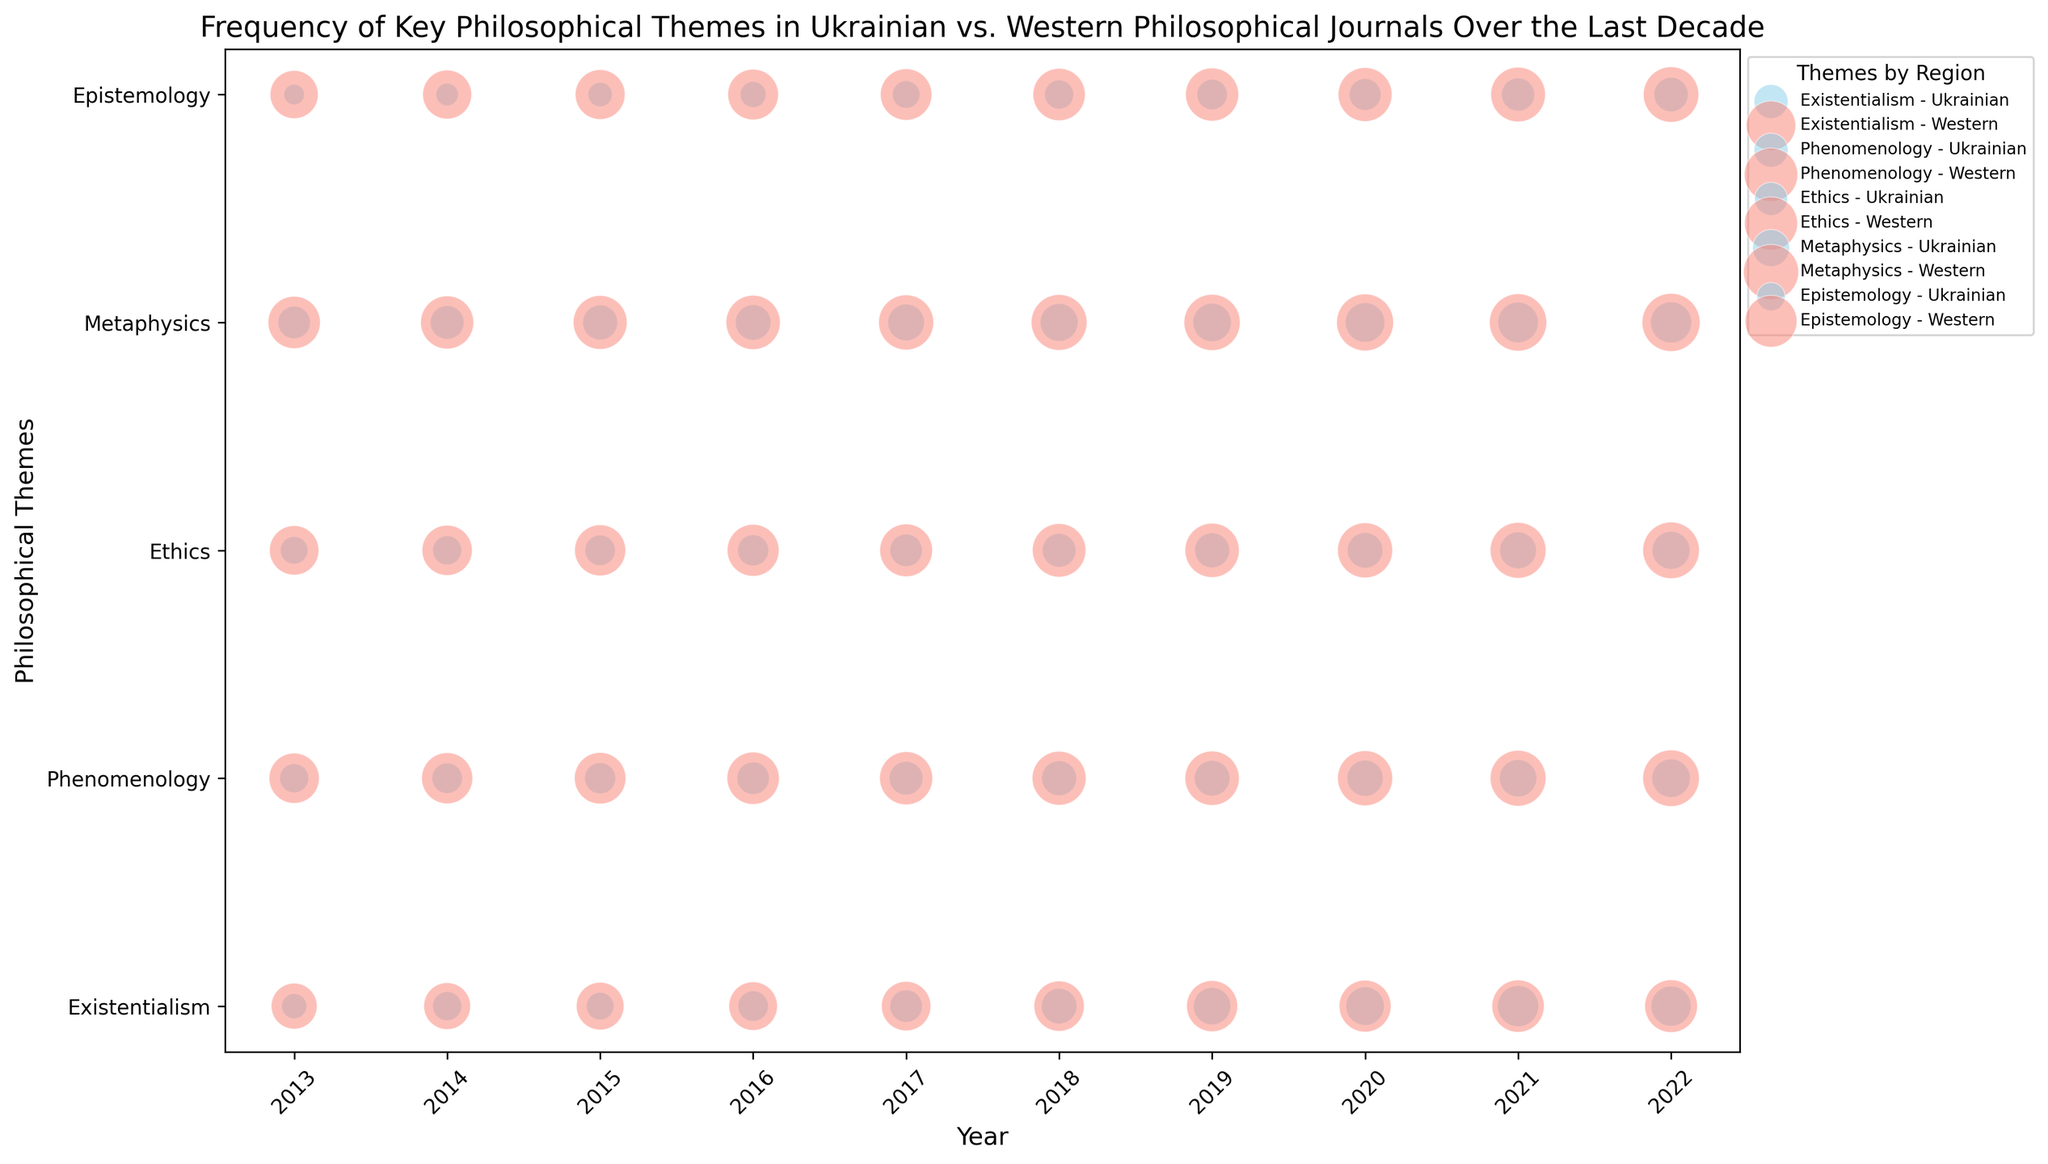What is the overall trend in the frequency of Existentialism in Ukrainian journals over the last decade? To determine the trend, observe the sizes of the bubbles representing Existentialism in Ukrainian journals from 2013 to 2022. The bubble size and frequency increase over time.
Answer: Increasing Which philosophical theme had the highest frequency in Ukrainian journals in 2022? Look at the bubble sizes for Ukrainian journals in the year 2022. Compare the sizes of bubbles for Existentialism, phenomenology, Ethics, Metaphysics, and Epistemology. Existentialism has the largest bubble.
Answer: Existentialism How much more frequently did Phenomenology appear in Western journals compared to Ukrainian journals in 2020? Find the frequency of Phenomenology in Western and Ukrainian journals in 2020. Western journals have 72, and Ukrainian journals have 31. The difference is 72 - 31.
Answer: 41 Compare the trend of Ethics in Ukrainian journals vs. Western journals over the last decade. Look at the bubbles for Ethics in both regions from 2013 to 2022. The bubbles (frequency) increase steadily over time in both cases, but Western journals start at a higher frequency and have a steeper increase.
Answer: Steeper increase in Western journals What is the combined frequency of Metaphysics and Epistemology in Ukrainian journals in 2018? Locate the frequencies of Metaphysics and Epistemology in Ukrainian journals for 2018: Metaphysics is 34 and Epistemology is 20. Add 34 + 20.
Answer: 54 Which region has a higher frequency of discussing Phenomenology in 2017, and by how much? Identify the Phenomenology bubble sizes for 2017 in both regions. Western journals have a frequency of 67, and Ukrainian journals have 27. The difference is 67 - 27.
Answer: Western, 40 What is the average frequency of Ethics in Ukrainian journals over the last decade? Sum the frequencies of Ethics in Ukrainian journals from 2013 to 2022: (18+20+22+23+25+27+29+30+32+34). The total is 260. Divide by the number of years, 260 / 10.
Answer: 26 Which philosophical theme shows the least variation in frequency across the last decade in Ukrainian journals? Compare the differences between the smallest and largest frequencies for each theme. Epistemology ranges from 10 to 28 (18 difference), which is the smallest range.
Answer: Epistemology 